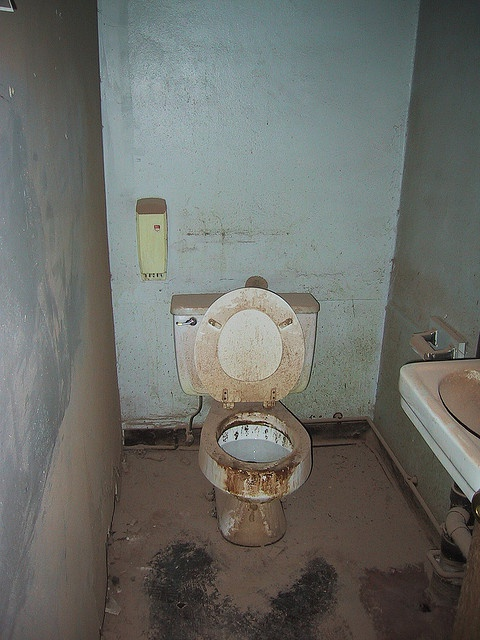Describe the objects in this image and their specific colors. I can see toilet in black, darkgray, gray, and maroon tones and sink in black, darkgray, and gray tones in this image. 